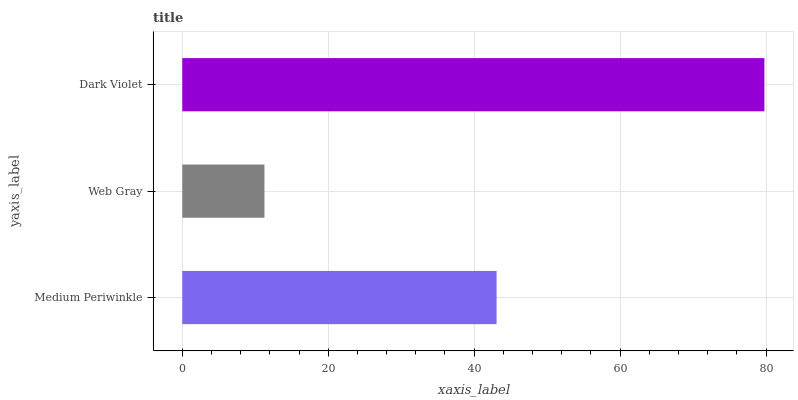Is Web Gray the minimum?
Answer yes or no. Yes. Is Dark Violet the maximum?
Answer yes or no. Yes. Is Dark Violet the minimum?
Answer yes or no. No. Is Web Gray the maximum?
Answer yes or no. No. Is Dark Violet greater than Web Gray?
Answer yes or no. Yes. Is Web Gray less than Dark Violet?
Answer yes or no. Yes. Is Web Gray greater than Dark Violet?
Answer yes or no. No. Is Dark Violet less than Web Gray?
Answer yes or no. No. Is Medium Periwinkle the high median?
Answer yes or no. Yes. Is Medium Periwinkle the low median?
Answer yes or no. Yes. Is Web Gray the high median?
Answer yes or no. No. Is Web Gray the low median?
Answer yes or no. No. 